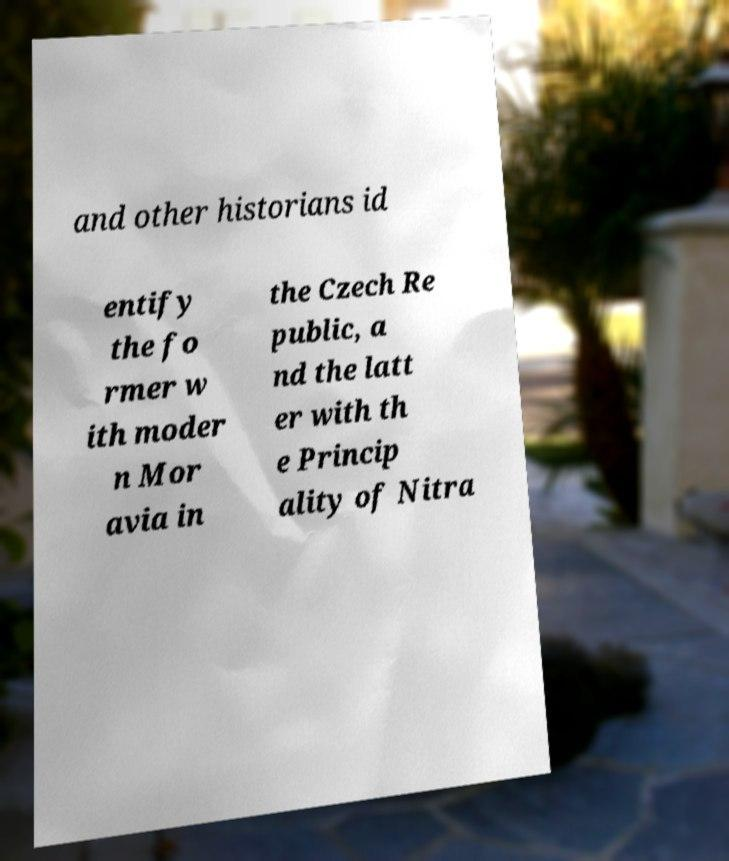Please read and relay the text visible in this image. What does it say? and other historians id entify the fo rmer w ith moder n Mor avia in the Czech Re public, a nd the latt er with th e Princip ality of Nitra 